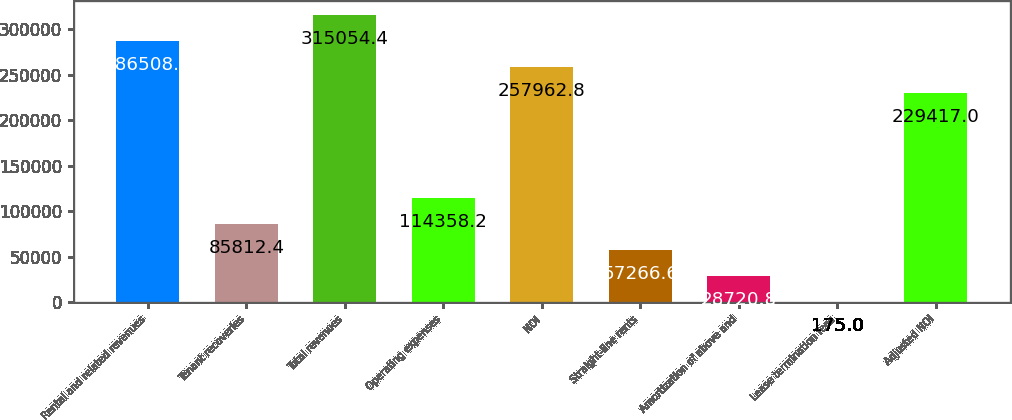Convert chart. <chart><loc_0><loc_0><loc_500><loc_500><bar_chart><fcel>Rental and related revenues<fcel>Tenant recoveries<fcel>Total revenues<fcel>Operating expenses<fcel>NOI<fcel>Straight-line rents<fcel>Amortization of above and<fcel>Lease termination fees<fcel>Adjusted NOI<nl><fcel>286509<fcel>85812.4<fcel>315054<fcel>114358<fcel>257963<fcel>57266.6<fcel>28720.8<fcel>175<fcel>229417<nl></chart> 